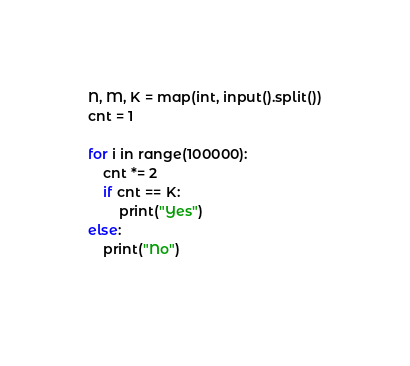Convert code to text. <code><loc_0><loc_0><loc_500><loc_500><_Python_>N, M, K = map(int, input().split())
cnt = 1

for i in range(100000):
    cnt *= 2
    if cnt == K:
        print("Yes")
else:
    print("No")
    </code> 